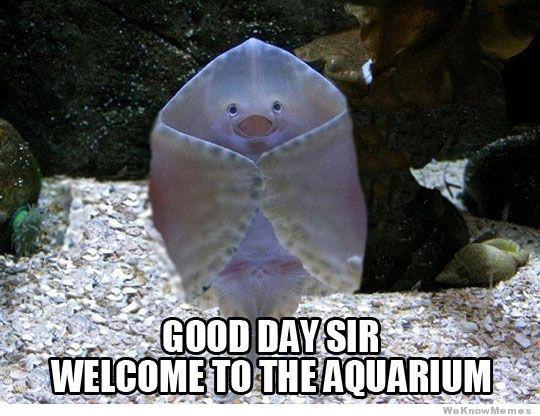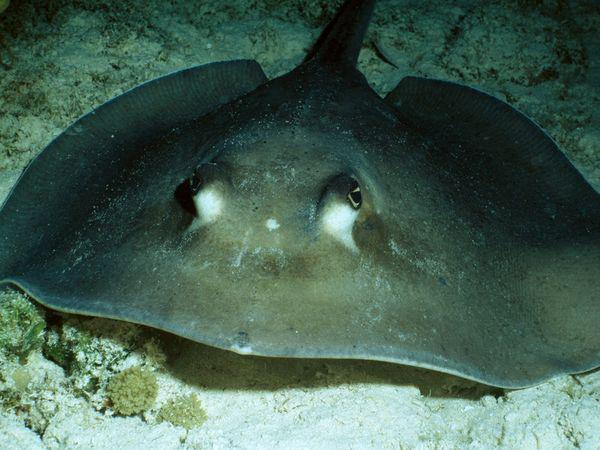The first image is the image on the left, the second image is the image on the right. Assess this claim about the two images: "The stingrays in each pair are looking in the opposite direction from each other.". Correct or not? Answer yes or no. No. The first image is the image on the left, the second image is the image on the right. Examine the images to the left and right. Is the description "There is a stingray facing right in the right image." accurate? Answer yes or no. No. 